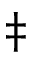<formula> <loc_0><loc_0><loc_500><loc_500>\ddagger</formula> 